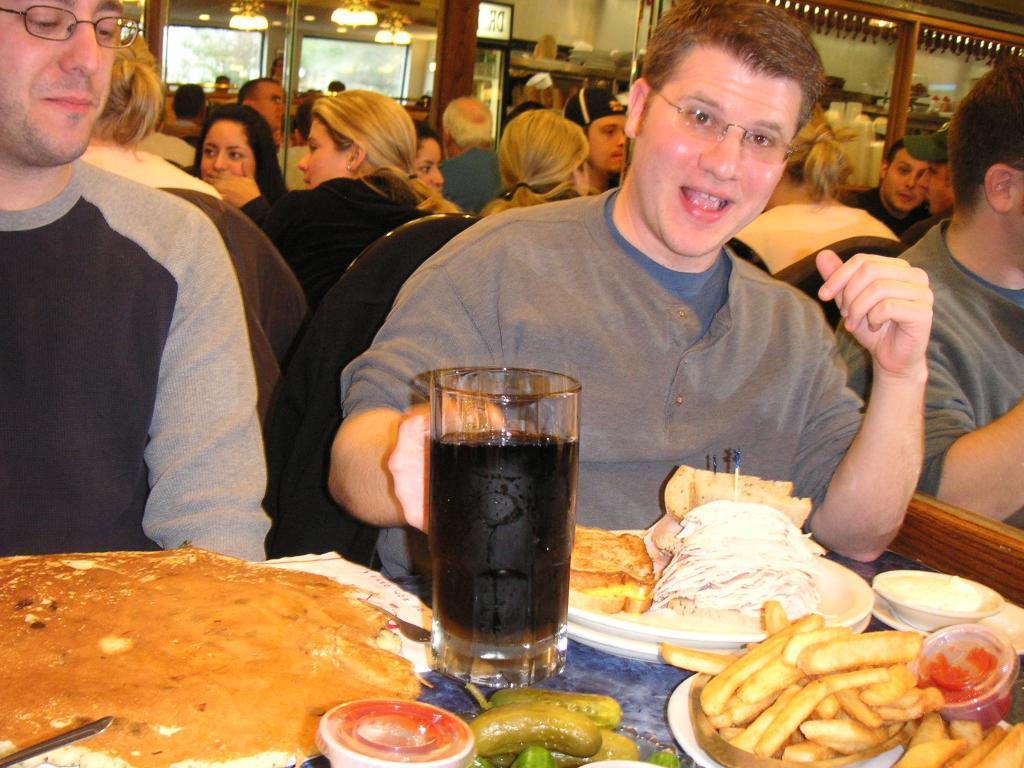How would you summarize this image in a sentence or two? In the image there are three men in the front sitting in front of table with food french fries,noodles,toasts,pickles,soft drinks on it and behind there are many ladies and men sitting, this seems to be clicked in a restaurant. 